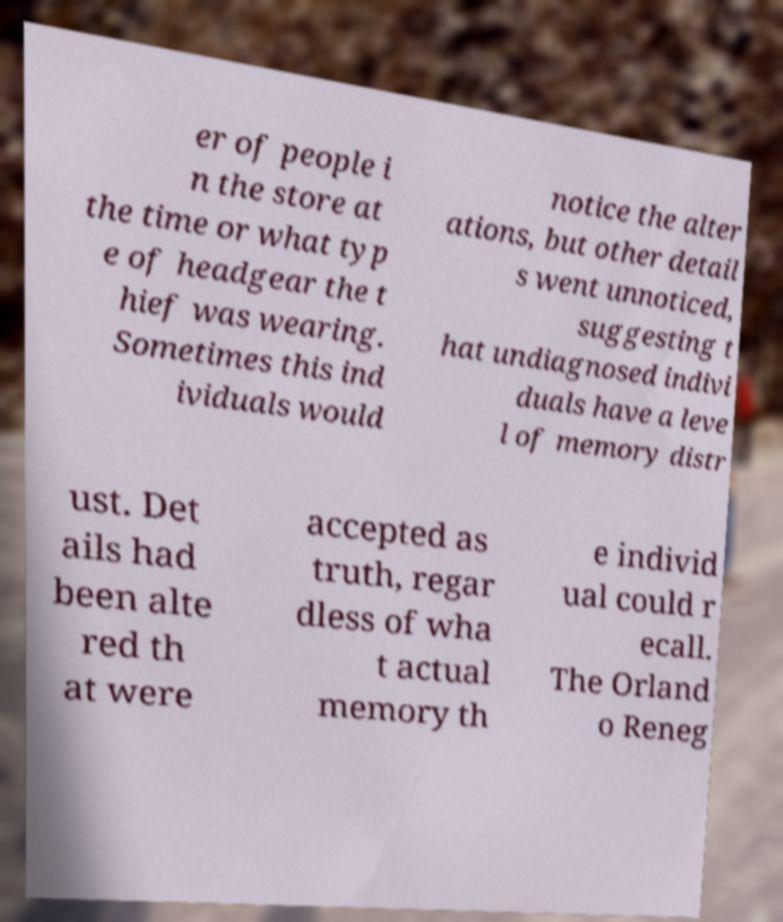For documentation purposes, I need the text within this image transcribed. Could you provide that? er of people i n the store at the time or what typ e of headgear the t hief was wearing. Sometimes this ind ividuals would notice the alter ations, but other detail s went unnoticed, suggesting t hat undiagnosed indivi duals have a leve l of memory distr ust. Det ails had been alte red th at were accepted as truth, regar dless of wha t actual memory th e individ ual could r ecall. The Orland o Reneg 